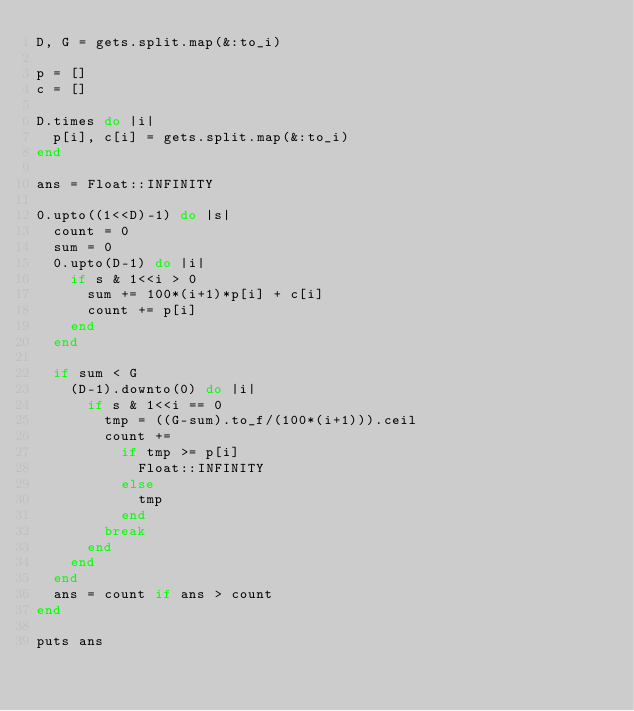Convert code to text. <code><loc_0><loc_0><loc_500><loc_500><_Ruby_>D, G = gets.split.map(&:to_i)

p = []
c = []

D.times do |i|
  p[i], c[i] = gets.split.map(&:to_i)
end

ans = Float::INFINITY

0.upto((1<<D)-1) do |s|
  count = 0
  sum = 0
  0.upto(D-1) do |i|
    if s & 1<<i > 0
      sum += 100*(i+1)*p[i] + c[i]
      count += p[i]
    end
  end

  if sum < G
    (D-1).downto(0) do |i|
      if s & 1<<i == 0
        tmp = ((G-sum).to_f/(100*(i+1))).ceil
        count +=
          if tmp >= p[i]
            Float::INFINITY
          else
            tmp
          end
        break
      end
    end
  end
  ans = count if ans > count
end

puts ans
</code> 